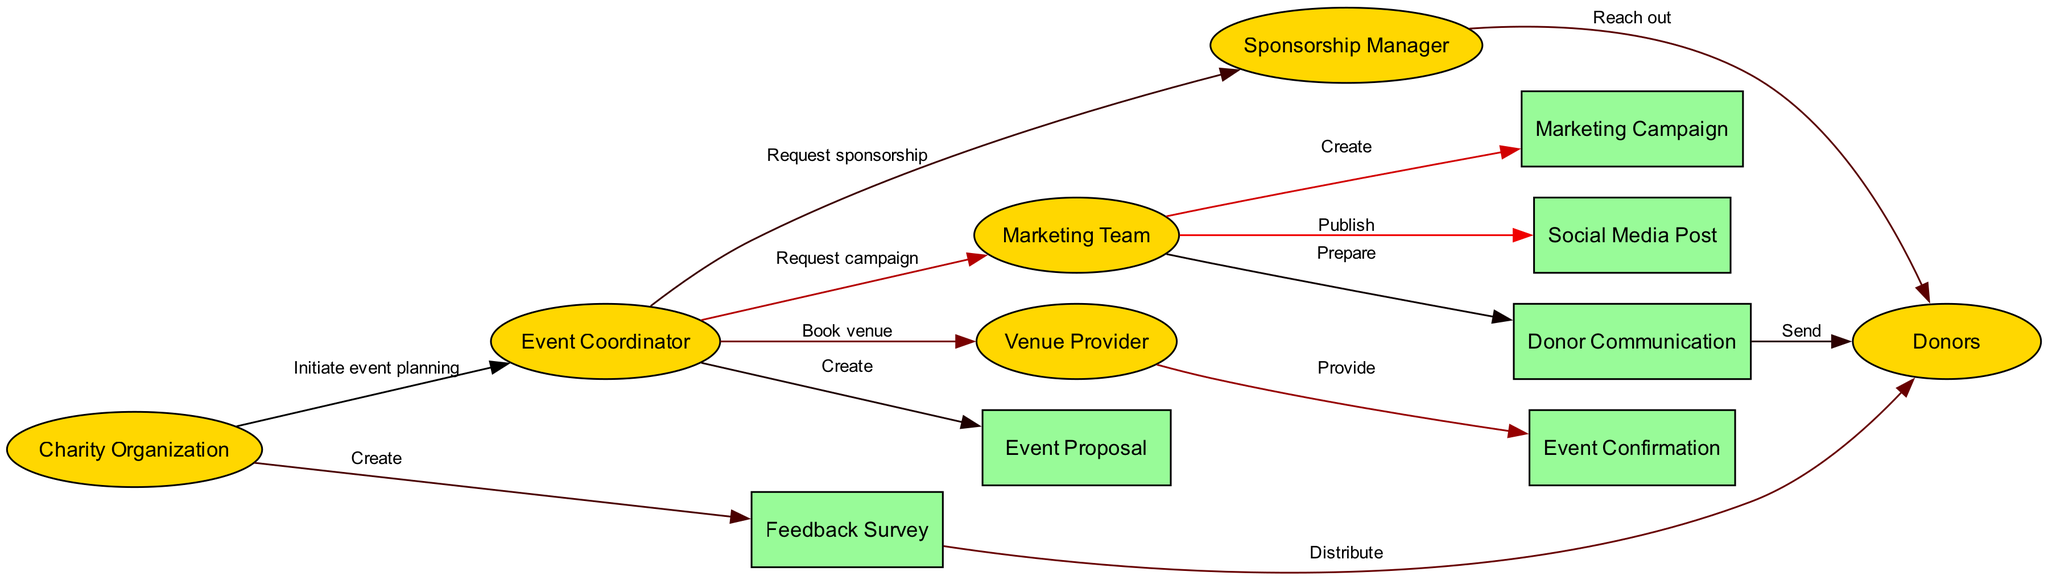What is the total number of actors in the diagram? The diagram lists six actors: Charity Organization, Event Coordinator, Sponsorship Manager, Marketing Team, Donors, and Venue Provider. Counting these gives a total of six actors.
Answer: 6 Which actor initiates the event planning? The Charity Organization is the actor that initiates the event planning by its connection to the Event Coordinator with the action "Initiate event planning."
Answer: Charity Organization What action follows the creation of the Event Proposal? After the Event Proposal is created by the Event Coordinator, the next action is for the Event Coordinator to request sponsorship from the Sponsorship Manager.
Answer: Request sponsorship How many entities are present in the diagram? The diagram contains six entities: Event Proposal, Marketing Campaign, Social Media Post, Donor Communication, Event Confirmation, and Feedback Survey. Counting these results in a total of six entities.
Answer: 6 What is the last interaction in the sequence? The last interaction is the distribution of the Feedback Survey to the Donors, which is shown as the final action in the sequence of events.
Answer: Distribute Which actor is responsible for creating the Marketing Campaign? The Marketing Team is responsible for creating the Marketing Campaign, as indicated by the arrow connecting Marketing Team to Marketing Campaign with the action "Create."
Answer: Marketing Team What is the purpose of the action labeled "Send"? The action labeled "Send" indicates that Donor Communication is being sent to the Donors, showing the communication flow directed at engaging them.
Answer: Engage donors Which actor communicates the Event Confirmation? The Venue Provider is the actor that provides the Event Confirmation after being booked by the Event Coordinator. This shows the flow of confirmation from the venue to the event organization process.
Answer: Venue Provider What type of communication follows the preparation of Donor Communication? The preparation of Donor Communication is followed by an action that involves sending that communication to the Donors, indicating direct donor engagement.
Answer: Sending communication 